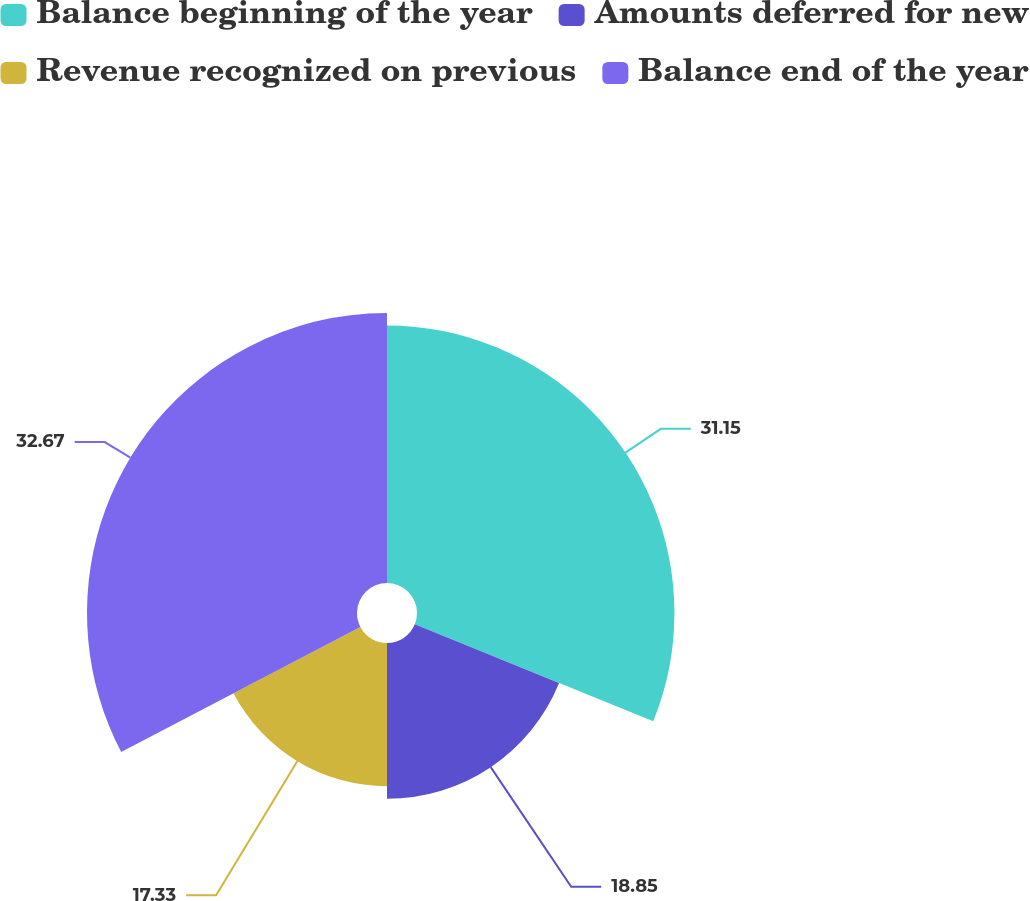<chart> <loc_0><loc_0><loc_500><loc_500><pie_chart><fcel>Balance beginning of the year<fcel>Amounts deferred for new<fcel>Revenue recognized on previous<fcel>Balance end of the year<nl><fcel>31.15%<fcel>18.85%<fcel>17.33%<fcel>32.67%<nl></chart> 